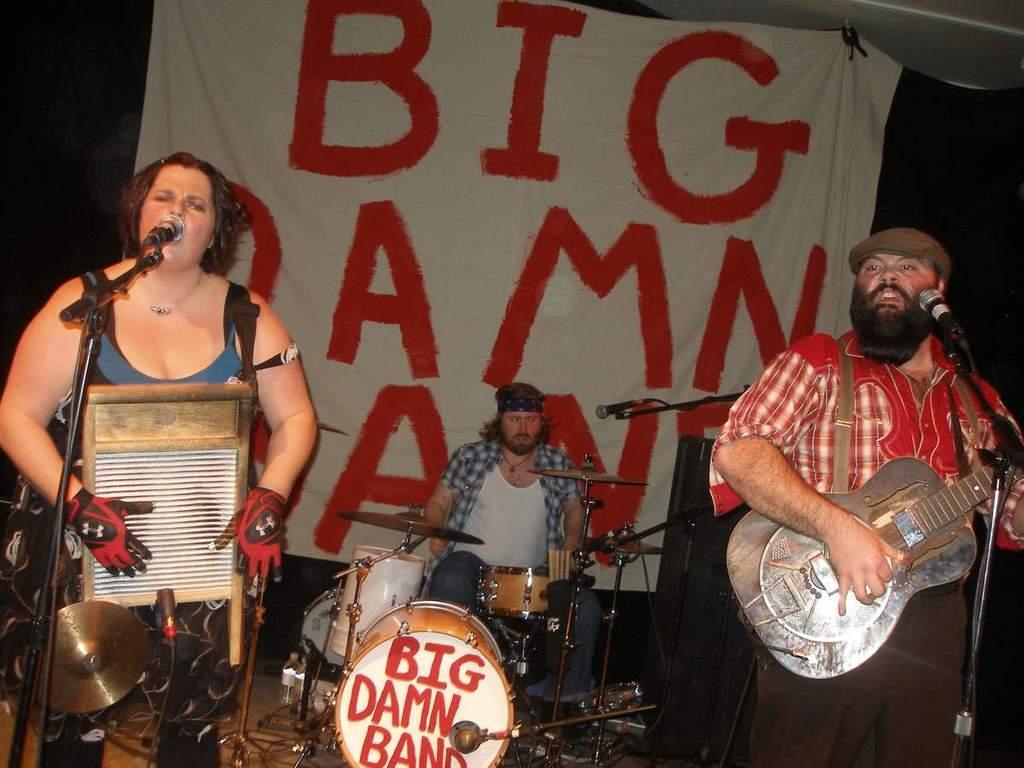In one or two sentences, can you explain what this image depicts? This woman is standing and singing in-front of mic. This man is playing a guitar and singing in-front of mic. This is white banner. This man is sitting and playing these musical instruments. 